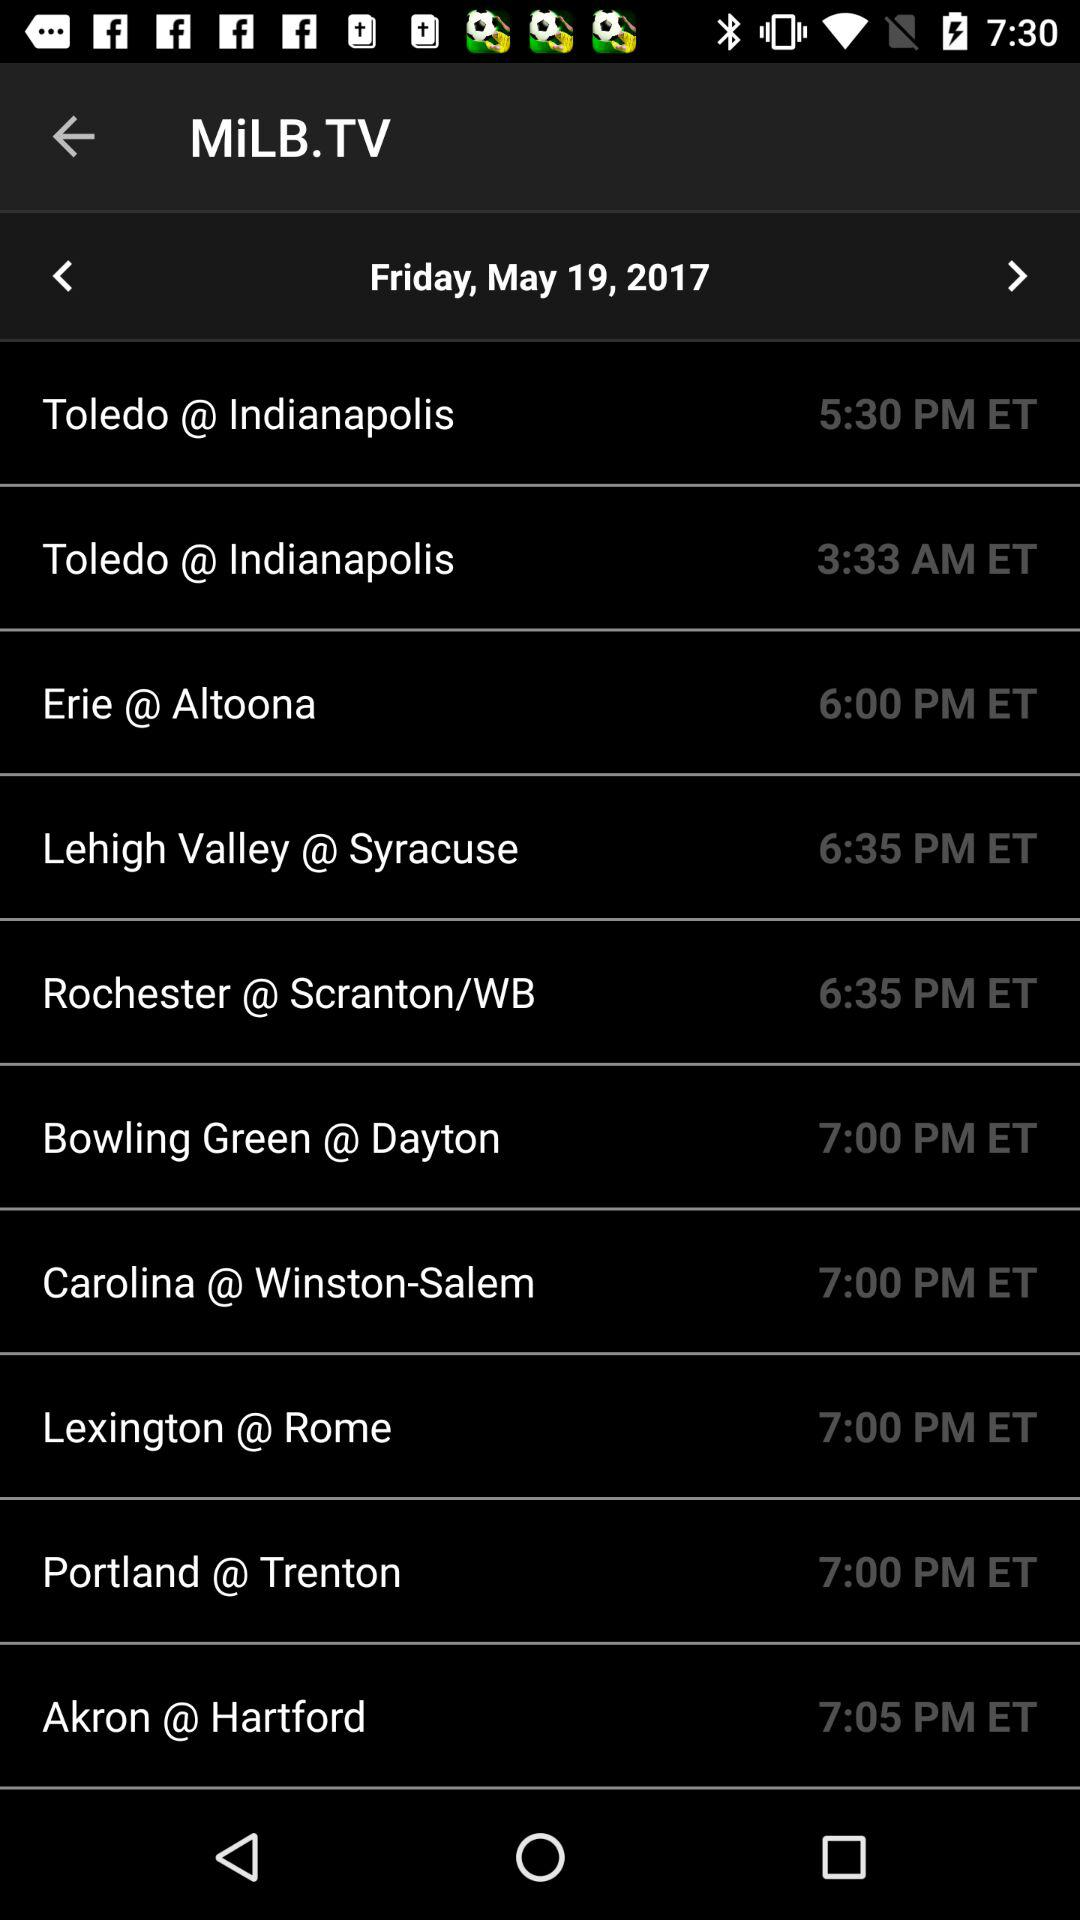What is the day on May 19? The day on May 19 is Friday. 